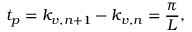<formula> <loc_0><loc_0><loc_500><loc_500>t _ { p } = k _ { v , n + 1 } - k _ { v , n } = \frac { \pi } { L } ,</formula> 